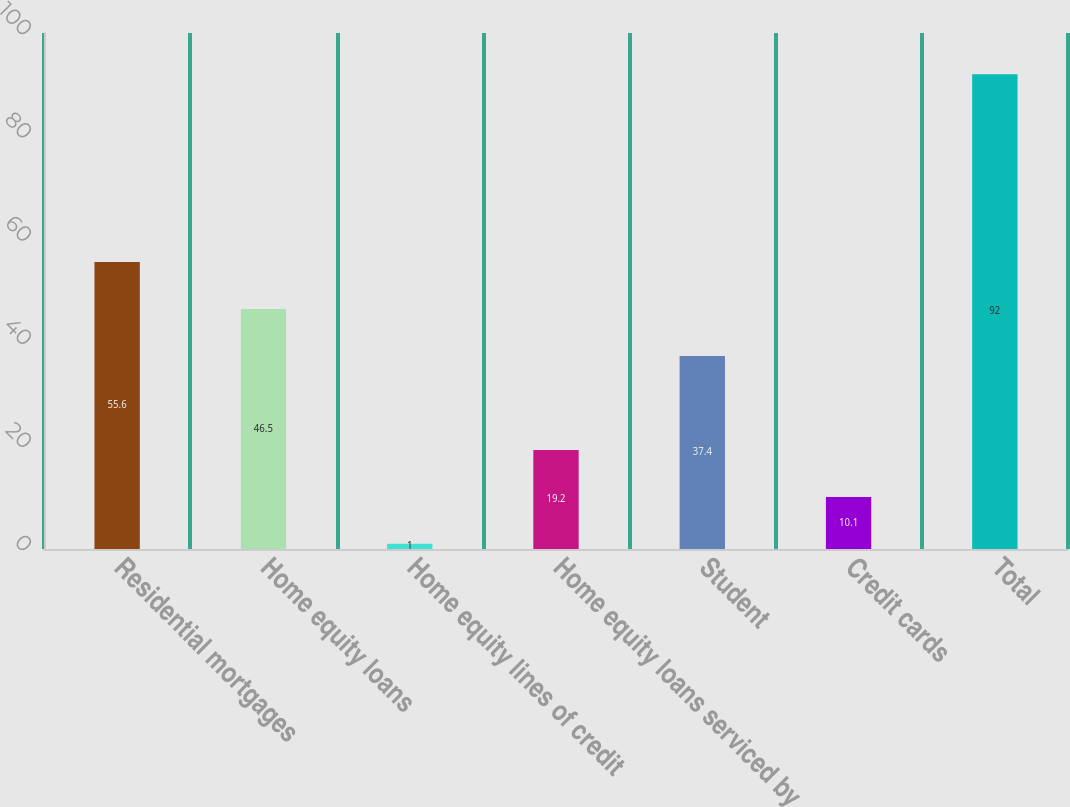<chart> <loc_0><loc_0><loc_500><loc_500><bar_chart><fcel>Residential mortgages<fcel>Home equity loans<fcel>Home equity lines of credit<fcel>Home equity loans serviced by<fcel>Student<fcel>Credit cards<fcel>Total<nl><fcel>55.6<fcel>46.5<fcel>1<fcel>19.2<fcel>37.4<fcel>10.1<fcel>92<nl></chart> 